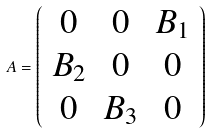<formula> <loc_0><loc_0><loc_500><loc_500>A = \left ( \begin{array} { c c c c c c } 0 & 0 & B _ { 1 } \\ B _ { 2 } & 0 & 0 \\ 0 & B _ { 3 } & 0 \end{array} \right )</formula> 